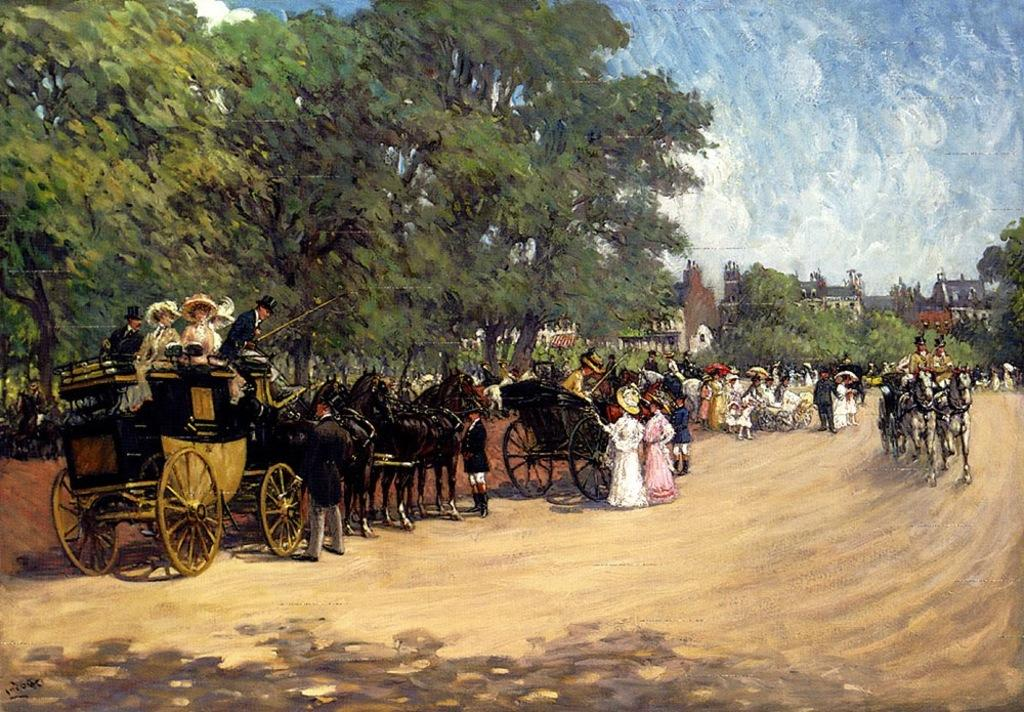What type of artwork is depicted in the image? The image appears to be a painting. What mode of transportation can be seen in the painting? There are horse carts in the image. What are the people in the painting doing? There are people standing and sitting in the carts. What type of structures are visible in the painting? There are buildings in the image. What type of vegetation is present in the painting? There are trees in the image. What part of the natural environment is visible in the painting? The sky is visible in the image. How many kittens are playing on the hill in the painting? There are no kittens or hills present in the painting; it features horse carts, people, buildings, trees, and a sky. 